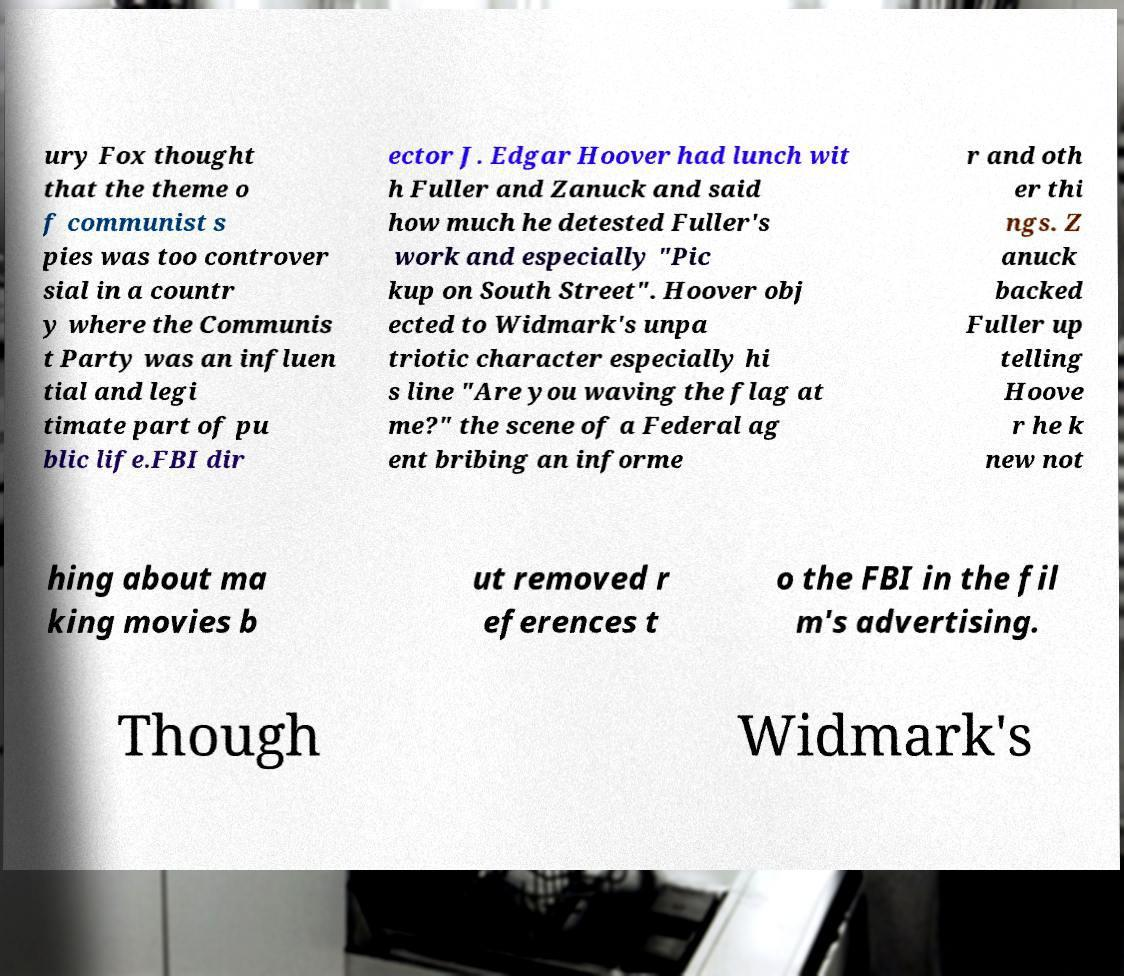For documentation purposes, I need the text within this image transcribed. Could you provide that? ury Fox thought that the theme o f communist s pies was too controver sial in a countr y where the Communis t Party was an influen tial and legi timate part of pu blic life.FBI dir ector J. Edgar Hoover had lunch wit h Fuller and Zanuck and said how much he detested Fuller's work and especially "Pic kup on South Street". Hoover obj ected to Widmark's unpa triotic character especially hi s line "Are you waving the flag at me?" the scene of a Federal ag ent bribing an informe r and oth er thi ngs. Z anuck backed Fuller up telling Hoove r he k new not hing about ma king movies b ut removed r eferences t o the FBI in the fil m's advertising. Though Widmark's 